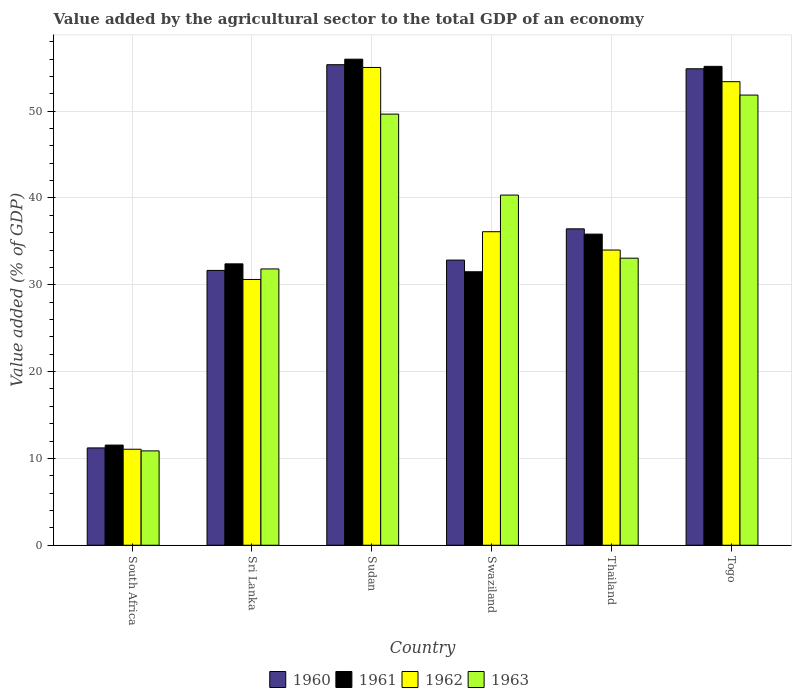How many different coloured bars are there?
Provide a succinct answer. 4. Are the number of bars per tick equal to the number of legend labels?
Provide a succinct answer. Yes. What is the label of the 5th group of bars from the left?
Offer a terse response. Thailand. In how many cases, is the number of bars for a given country not equal to the number of legend labels?
Provide a succinct answer. 0. What is the value added by the agricultural sector to the total GDP in 1962 in Thailand?
Ensure brevity in your answer.  34. Across all countries, what is the maximum value added by the agricultural sector to the total GDP in 1962?
Offer a very short reply. 55.03. Across all countries, what is the minimum value added by the agricultural sector to the total GDP in 1963?
Provide a short and direct response. 10.87. In which country was the value added by the agricultural sector to the total GDP in 1960 maximum?
Provide a succinct answer. Sudan. In which country was the value added by the agricultural sector to the total GDP in 1962 minimum?
Provide a short and direct response. South Africa. What is the total value added by the agricultural sector to the total GDP in 1961 in the graph?
Make the answer very short. 222.43. What is the difference between the value added by the agricultural sector to the total GDP in 1963 in Sudan and that in Swaziland?
Keep it short and to the point. 9.32. What is the difference between the value added by the agricultural sector to the total GDP in 1960 in South Africa and the value added by the agricultural sector to the total GDP in 1961 in Thailand?
Provide a succinct answer. -24.63. What is the average value added by the agricultural sector to the total GDP in 1962 per country?
Provide a short and direct response. 36.7. What is the difference between the value added by the agricultural sector to the total GDP of/in 1961 and value added by the agricultural sector to the total GDP of/in 1962 in Sri Lanka?
Keep it short and to the point. 1.8. In how many countries, is the value added by the agricultural sector to the total GDP in 1963 greater than 2 %?
Your answer should be compact. 6. What is the ratio of the value added by the agricultural sector to the total GDP in 1963 in Swaziland to that in Togo?
Your answer should be compact. 0.78. Is the value added by the agricultural sector to the total GDP in 1961 in Sri Lanka less than that in Thailand?
Provide a short and direct response. Yes. Is the difference between the value added by the agricultural sector to the total GDP in 1961 in South Africa and Thailand greater than the difference between the value added by the agricultural sector to the total GDP in 1962 in South Africa and Thailand?
Offer a very short reply. No. What is the difference between the highest and the second highest value added by the agricultural sector to the total GDP in 1961?
Keep it short and to the point. -19.32. What is the difference between the highest and the lowest value added by the agricultural sector to the total GDP in 1963?
Your response must be concise. 40.98. Is it the case that in every country, the sum of the value added by the agricultural sector to the total GDP in 1960 and value added by the agricultural sector to the total GDP in 1962 is greater than the value added by the agricultural sector to the total GDP in 1963?
Give a very brief answer. Yes. Are the values on the major ticks of Y-axis written in scientific E-notation?
Provide a succinct answer. No. Does the graph contain any zero values?
Make the answer very short. No. Does the graph contain grids?
Keep it short and to the point. Yes. Where does the legend appear in the graph?
Provide a succinct answer. Bottom center. How many legend labels are there?
Make the answer very short. 4. What is the title of the graph?
Offer a terse response. Value added by the agricultural sector to the total GDP of an economy. Does "1985" appear as one of the legend labels in the graph?
Offer a very short reply. No. What is the label or title of the X-axis?
Offer a terse response. Country. What is the label or title of the Y-axis?
Provide a succinct answer. Value added (% of GDP). What is the Value added (% of GDP) in 1960 in South Africa?
Offer a terse response. 11.21. What is the Value added (% of GDP) of 1961 in South Africa?
Provide a succinct answer. 11.54. What is the Value added (% of GDP) in 1962 in South Africa?
Provide a succinct answer. 11.06. What is the Value added (% of GDP) of 1963 in South Africa?
Provide a succinct answer. 10.87. What is the Value added (% of GDP) in 1960 in Sri Lanka?
Keep it short and to the point. 31.66. What is the Value added (% of GDP) of 1961 in Sri Lanka?
Your answer should be compact. 32.41. What is the Value added (% of GDP) in 1962 in Sri Lanka?
Provide a succinct answer. 30.61. What is the Value added (% of GDP) of 1963 in Sri Lanka?
Make the answer very short. 31.83. What is the Value added (% of GDP) in 1960 in Sudan?
Provide a succinct answer. 55.35. What is the Value added (% of GDP) in 1961 in Sudan?
Give a very brief answer. 55.99. What is the Value added (% of GDP) of 1962 in Sudan?
Offer a terse response. 55.03. What is the Value added (% of GDP) in 1963 in Sudan?
Offer a terse response. 49.66. What is the Value added (% of GDP) of 1960 in Swaziland?
Make the answer very short. 32.84. What is the Value added (% of GDP) in 1961 in Swaziland?
Your answer should be very brief. 31.5. What is the Value added (% of GDP) in 1962 in Swaziland?
Provide a succinct answer. 36.11. What is the Value added (% of GDP) in 1963 in Swaziland?
Your answer should be compact. 40.33. What is the Value added (% of GDP) in 1960 in Thailand?
Give a very brief answer. 36.44. What is the Value added (% of GDP) in 1961 in Thailand?
Provide a short and direct response. 35.84. What is the Value added (% of GDP) in 1962 in Thailand?
Your answer should be very brief. 34. What is the Value added (% of GDP) of 1963 in Thailand?
Your answer should be compact. 33.07. What is the Value added (% of GDP) of 1960 in Togo?
Ensure brevity in your answer.  54.88. What is the Value added (% of GDP) of 1961 in Togo?
Provide a short and direct response. 55.16. What is the Value added (% of GDP) in 1962 in Togo?
Ensure brevity in your answer.  53.4. What is the Value added (% of GDP) of 1963 in Togo?
Your answer should be compact. 51.85. Across all countries, what is the maximum Value added (% of GDP) in 1960?
Offer a terse response. 55.35. Across all countries, what is the maximum Value added (% of GDP) in 1961?
Make the answer very short. 55.99. Across all countries, what is the maximum Value added (% of GDP) in 1962?
Provide a short and direct response. 55.03. Across all countries, what is the maximum Value added (% of GDP) in 1963?
Provide a succinct answer. 51.85. Across all countries, what is the minimum Value added (% of GDP) of 1960?
Give a very brief answer. 11.21. Across all countries, what is the minimum Value added (% of GDP) in 1961?
Make the answer very short. 11.54. Across all countries, what is the minimum Value added (% of GDP) of 1962?
Offer a terse response. 11.06. Across all countries, what is the minimum Value added (% of GDP) in 1963?
Your answer should be compact. 10.87. What is the total Value added (% of GDP) in 1960 in the graph?
Offer a very short reply. 222.39. What is the total Value added (% of GDP) of 1961 in the graph?
Your answer should be very brief. 222.44. What is the total Value added (% of GDP) of 1962 in the graph?
Provide a succinct answer. 220.21. What is the total Value added (% of GDP) of 1963 in the graph?
Your answer should be compact. 217.6. What is the difference between the Value added (% of GDP) in 1960 in South Africa and that in Sri Lanka?
Provide a short and direct response. -20.45. What is the difference between the Value added (% of GDP) in 1961 in South Africa and that in Sri Lanka?
Give a very brief answer. -20.87. What is the difference between the Value added (% of GDP) of 1962 in South Africa and that in Sri Lanka?
Your answer should be very brief. -19.56. What is the difference between the Value added (% of GDP) of 1963 in South Africa and that in Sri Lanka?
Your answer should be compact. -20.96. What is the difference between the Value added (% of GDP) of 1960 in South Africa and that in Sudan?
Offer a terse response. -44.14. What is the difference between the Value added (% of GDP) of 1961 in South Africa and that in Sudan?
Make the answer very short. -44.45. What is the difference between the Value added (% of GDP) in 1962 in South Africa and that in Sudan?
Provide a succinct answer. -43.98. What is the difference between the Value added (% of GDP) of 1963 in South Africa and that in Sudan?
Offer a terse response. -38.79. What is the difference between the Value added (% of GDP) in 1960 in South Africa and that in Swaziland?
Your answer should be compact. -21.63. What is the difference between the Value added (% of GDP) of 1961 in South Africa and that in Swaziland?
Make the answer very short. -19.96. What is the difference between the Value added (% of GDP) in 1962 in South Africa and that in Swaziland?
Your answer should be very brief. -25.06. What is the difference between the Value added (% of GDP) of 1963 in South Africa and that in Swaziland?
Your answer should be compact. -29.46. What is the difference between the Value added (% of GDP) in 1960 in South Africa and that in Thailand?
Your response must be concise. -25.23. What is the difference between the Value added (% of GDP) in 1961 in South Africa and that in Thailand?
Your response must be concise. -24.3. What is the difference between the Value added (% of GDP) of 1962 in South Africa and that in Thailand?
Your answer should be very brief. -22.95. What is the difference between the Value added (% of GDP) of 1963 in South Africa and that in Thailand?
Offer a terse response. -22.2. What is the difference between the Value added (% of GDP) of 1960 in South Africa and that in Togo?
Keep it short and to the point. -43.67. What is the difference between the Value added (% of GDP) in 1961 in South Africa and that in Togo?
Make the answer very short. -43.62. What is the difference between the Value added (% of GDP) in 1962 in South Africa and that in Togo?
Your answer should be very brief. -42.34. What is the difference between the Value added (% of GDP) of 1963 in South Africa and that in Togo?
Your response must be concise. -40.98. What is the difference between the Value added (% of GDP) in 1960 in Sri Lanka and that in Sudan?
Give a very brief answer. -23.7. What is the difference between the Value added (% of GDP) in 1961 in Sri Lanka and that in Sudan?
Offer a very short reply. -23.58. What is the difference between the Value added (% of GDP) in 1962 in Sri Lanka and that in Sudan?
Keep it short and to the point. -24.42. What is the difference between the Value added (% of GDP) in 1963 in Sri Lanka and that in Sudan?
Your answer should be very brief. -17.83. What is the difference between the Value added (% of GDP) of 1960 in Sri Lanka and that in Swaziland?
Give a very brief answer. -1.19. What is the difference between the Value added (% of GDP) of 1961 in Sri Lanka and that in Swaziland?
Provide a succinct answer. 0.91. What is the difference between the Value added (% of GDP) in 1962 in Sri Lanka and that in Swaziland?
Keep it short and to the point. -5.5. What is the difference between the Value added (% of GDP) in 1963 in Sri Lanka and that in Swaziland?
Give a very brief answer. -8.51. What is the difference between the Value added (% of GDP) in 1960 in Sri Lanka and that in Thailand?
Give a very brief answer. -4.79. What is the difference between the Value added (% of GDP) in 1961 in Sri Lanka and that in Thailand?
Give a very brief answer. -3.43. What is the difference between the Value added (% of GDP) in 1962 in Sri Lanka and that in Thailand?
Give a very brief answer. -3.39. What is the difference between the Value added (% of GDP) in 1963 in Sri Lanka and that in Thailand?
Provide a succinct answer. -1.24. What is the difference between the Value added (% of GDP) in 1960 in Sri Lanka and that in Togo?
Provide a succinct answer. -23.23. What is the difference between the Value added (% of GDP) of 1961 in Sri Lanka and that in Togo?
Your answer should be very brief. -22.75. What is the difference between the Value added (% of GDP) in 1962 in Sri Lanka and that in Togo?
Make the answer very short. -22.78. What is the difference between the Value added (% of GDP) of 1963 in Sri Lanka and that in Togo?
Keep it short and to the point. -20.03. What is the difference between the Value added (% of GDP) in 1960 in Sudan and that in Swaziland?
Provide a succinct answer. 22.51. What is the difference between the Value added (% of GDP) in 1961 in Sudan and that in Swaziland?
Your response must be concise. 24.49. What is the difference between the Value added (% of GDP) in 1962 in Sudan and that in Swaziland?
Offer a terse response. 18.92. What is the difference between the Value added (% of GDP) of 1963 in Sudan and that in Swaziland?
Your response must be concise. 9.32. What is the difference between the Value added (% of GDP) of 1960 in Sudan and that in Thailand?
Provide a succinct answer. 18.91. What is the difference between the Value added (% of GDP) in 1961 in Sudan and that in Thailand?
Make the answer very short. 20.15. What is the difference between the Value added (% of GDP) of 1962 in Sudan and that in Thailand?
Make the answer very short. 21.03. What is the difference between the Value added (% of GDP) of 1963 in Sudan and that in Thailand?
Provide a short and direct response. 16.59. What is the difference between the Value added (% of GDP) of 1960 in Sudan and that in Togo?
Your response must be concise. 0.47. What is the difference between the Value added (% of GDP) in 1961 in Sudan and that in Togo?
Offer a terse response. 0.83. What is the difference between the Value added (% of GDP) of 1962 in Sudan and that in Togo?
Your answer should be very brief. 1.64. What is the difference between the Value added (% of GDP) in 1963 in Sudan and that in Togo?
Your answer should be very brief. -2.19. What is the difference between the Value added (% of GDP) in 1960 in Swaziland and that in Thailand?
Make the answer very short. -3.6. What is the difference between the Value added (% of GDP) of 1961 in Swaziland and that in Thailand?
Offer a very short reply. -4.34. What is the difference between the Value added (% of GDP) of 1962 in Swaziland and that in Thailand?
Keep it short and to the point. 2.11. What is the difference between the Value added (% of GDP) in 1963 in Swaziland and that in Thailand?
Offer a very short reply. 7.27. What is the difference between the Value added (% of GDP) of 1960 in Swaziland and that in Togo?
Give a very brief answer. -22.04. What is the difference between the Value added (% of GDP) in 1961 in Swaziland and that in Togo?
Keep it short and to the point. -23.66. What is the difference between the Value added (% of GDP) in 1962 in Swaziland and that in Togo?
Provide a short and direct response. -17.28. What is the difference between the Value added (% of GDP) of 1963 in Swaziland and that in Togo?
Offer a terse response. -11.52. What is the difference between the Value added (% of GDP) in 1960 in Thailand and that in Togo?
Your response must be concise. -18.44. What is the difference between the Value added (% of GDP) in 1961 in Thailand and that in Togo?
Make the answer very short. -19.32. What is the difference between the Value added (% of GDP) of 1962 in Thailand and that in Togo?
Provide a short and direct response. -19.39. What is the difference between the Value added (% of GDP) of 1963 in Thailand and that in Togo?
Ensure brevity in your answer.  -18.79. What is the difference between the Value added (% of GDP) in 1960 in South Africa and the Value added (% of GDP) in 1961 in Sri Lanka?
Make the answer very short. -21.2. What is the difference between the Value added (% of GDP) of 1960 in South Africa and the Value added (% of GDP) of 1962 in Sri Lanka?
Offer a very short reply. -19.4. What is the difference between the Value added (% of GDP) in 1960 in South Africa and the Value added (% of GDP) in 1963 in Sri Lanka?
Keep it short and to the point. -20.62. What is the difference between the Value added (% of GDP) in 1961 in South Africa and the Value added (% of GDP) in 1962 in Sri Lanka?
Provide a short and direct response. -19.08. What is the difference between the Value added (% of GDP) of 1961 in South Africa and the Value added (% of GDP) of 1963 in Sri Lanka?
Ensure brevity in your answer.  -20.29. What is the difference between the Value added (% of GDP) in 1962 in South Africa and the Value added (% of GDP) in 1963 in Sri Lanka?
Offer a very short reply. -20.77. What is the difference between the Value added (% of GDP) in 1960 in South Africa and the Value added (% of GDP) in 1961 in Sudan?
Make the answer very short. -44.78. What is the difference between the Value added (% of GDP) in 1960 in South Africa and the Value added (% of GDP) in 1962 in Sudan?
Make the answer very short. -43.82. What is the difference between the Value added (% of GDP) in 1960 in South Africa and the Value added (% of GDP) in 1963 in Sudan?
Keep it short and to the point. -38.45. What is the difference between the Value added (% of GDP) in 1961 in South Africa and the Value added (% of GDP) in 1962 in Sudan?
Your answer should be compact. -43.5. What is the difference between the Value added (% of GDP) in 1961 in South Africa and the Value added (% of GDP) in 1963 in Sudan?
Offer a very short reply. -38.12. What is the difference between the Value added (% of GDP) of 1962 in South Africa and the Value added (% of GDP) of 1963 in Sudan?
Offer a terse response. -38.6. What is the difference between the Value added (% of GDP) of 1960 in South Africa and the Value added (% of GDP) of 1961 in Swaziland?
Provide a succinct answer. -20.29. What is the difference between the Value added (% of GDP) in 1960 in South Africa and the Value added (% of GDP) in 1962 in Swaziland?
Make the answer very short. -24.9. What is the difference between the Value added (% of GDP) in 1960 in South Africa and the Value added (% of GDP) in 1963 in Swaziland?
Keep it short and to the point. -29.12. What is the difference between the Value added (% of GDP) in 1961 in South Africa and the Value added (% of GDP) in 1962 in Swaziland?
Offer a terse response. -24.58. What is the difference between the Value added (% of GDP) in 1961 in South Africa and the Value added (% of GDP) in 1963 in Swaziland?
Provide a short and direct response. -28.8. What is the difference between the Value added (% of GDP) of 1962 in South Africa and the Value added (% of GDP) of 1963 in Swaziland?
Offer a terse response. -29.28. What is the difference between the Value added (% of GDP) in 1960 in South Africa and the Value added (% of GDP) in 1961 in Thailand?
Your response must be concise. -24.63. What is the difference between the Value added (% of GDP) in 1960 in South Africa and the Value added (% of GDP) in 1962 in Thailand?
Keep it short and to the point. -22.79. What is the difference between the Value added (% of GDP) of 1960 in South Africa and the Value added (% of GDP) of 1963 in Thailand?
Keep it short and to the point. -21.86. What is the difference between the Value added (% of GDP) in 1961 in South Africa and the Value added (% of GDP) in 1962 in Thailand?
Give a very brief answer. -22.47. What is the difference between the Value added (% of GDP) in 1961 in South Africa and the Value added (% of GDP) in 1963 in Thailand?
Provide a short and direct response. -21.53. What is the difference between the Value added (% of GDP) of 1962 in South Africa and the Value added (% of GDP) of 1963 in Thailand?
Offer a very short reply. -22.01. What is the difference between the Value added (% of GDP) in 1960 in South Africa and the Value added (% of GDP) in 1961 in Togo?
Keep it short and to the point. -43.95. What is the difference between the Value added (% of GDP) of 1960 in South Africa and the Value added (% of GDP) of 1962 in Togo?
Offer a terse response. -42.18. What is the difference between the Value added (% of GDP) of 1960 in South Africa and the Value added (% of GDP) of 1963 in Togo?
Your answer should be compact. -40.64. What is the difference between the Value added (% of GDP) of 1961 in South Africa and the Value added (% of GDP) of 1962 in Togo?
Your answer should be compact. -41.86. What is the difference between the Value added (% of GDP) in 1961 in South Africa and the Value added (% of GDP) in 1963 in Togo?
Keep it short and to the point. -40.31. What is the difference between the Value added (% of GDP) of 1962 in South Africa and the Value added (% of GDP) of 1963 in Togo?
Offer a terse response. -40.8. What is the difference between the Value added (% of GDP) in 1960 in Sri Lanka and the Value added (% of GDP) in 1961 in Sudan?
Your answer should be compact. -24.33. What is the difference between the Value added (% of GDP) in 1960 in Sri Lanka and the Value added (% of GDP) in 1962 in Sudan?
Ensure brevity in your answer.  -23.38. What is the difference between the Value added (% of GDP) of 1960 in Sri Lanka and the Value added (% of GDP) of 1963 in Sudan?
Give a very brief answer. -18. What is the difference between the Value added (% of GDP) in 1961 in Sri Lanka and the Value added (% of GDP) in 1962 in Sudan?
Ensure brevity in your answer.  -22.62. What is the difference between the Value added (% of GDP) of 1961 in Sri Lanka and the Value added (% of GDP) of 1963 in Sudan?
Keep it short and to the point. -17.25. What is the difference between the Value added (% of GDP) of 1962 in Sri Lanka and the Value added (% of GDP) of 1963 in Sudan?
Give a very brief answer. -19.04. What is the difference between the Value added (% of GDP) of 1960 in Sri Lanka and the Value added (% of GDP) of 1961 in Swaziland?
Your answer should be very brief. 0.16. What is the difference between the Value added (% of GDP) in 1960 in Sri Lanka and the Value added (% of GDP) in 1962 in Swaziland?
Make the answer very short. -4.46. What is the difference between the Value added (% of GDP) of 1960 in Sri Lanka and the Value added (% of GDP) of 1963 in Swaziland?
Provide a succinct answer. -8.68. What is the difference between the Value added (% of GDP) in 1961 in Sri Lanka and the Value added (% of GDP) in 1962 in Swaziland?
Your answer should be compact. -3.7. What is the difference between the Value added (% of GDP) of 1961 in Sri Lanka and the Value added (% of GDP) of 1963 in Swaziland?
Your response must be concise. -7.92. What is the difference between the Value added (% of GDP) in 1962 in Sri Lanka and the Value added (% of GDP) in 1963 in Swaziland?
Make the answer very short. -9.72. What is the difference between the Value added (% of GDP) in 1960 in Sri Lanka and the Value added (% of GDP) in 1961 in Thailand?
Keep it short and to the point. -4.18. What is the difference between the Value added (% of GDP) in 1960 in Sri Lanka and the Value added (% of GDP) in 1962 in Thailand?
Provide a succinct answer. -2.35. What is the difference between the Value added (% of GDP) of 1960 in Sri Lanka and the Value added (% of GDP) of 1963 in Thailand?
Your response must be concise. -1.41. What is the difference between the Value added (% of GDP) in 1961 in Sri Lanka and the Value added (% of GDP) in 1962 in Thailand?
Your answer should be compact. -1.59. What is the difference between the Value added (% of GDP) of 1961 in Sri Lanka and the Value added (% of GDP) of 1963 in Thailand?
Make the answer very short. -0.65. What is the difference between the Value added (% of GDP) of 1962 in Sri Lanka and the Value added (% of GDP) of 1963 in Thailand?
Make the answer very short. -2.45. What is the difference between the Value added (% of GDP) of 1960 in Sri Lanka and the Value added (% of GDP) of 1961 in Togo?
Your answer should be very brief. -23.51. What is the difference between the Value added (% of GDP) in 1960 in Sri Lanka and the Value added (% of GDP) in 1962 in Togo?
Provide a succinct answer. -21.74. What is the difference between the Value added (% of GDP) of 1960 in Sri Lanka and the Value added (% of GDP) of 1963 in Togo?
Ensure brevity in your answer.  -20.2. What is the difference between the Value added (% of GDP) of 1961 in Sri Lanka and the Value added (% of GDP) of 1962 in Togo?
Your answer should be compact. -20.98. What is the difference between the Value added (% of GDP) of 1961 in Sri Lanka and the Value added (% of GDP) of 1963 in Togo?
Provide a succinct answer. -19.44. What is the difference between the Value added (% of GDP) in 1962 in Sri Lanka and the Value added (% of GDP) in 1963 in Togo?
Provide a succinct answer. -21.24. What is the difference between the Value added (% of GDP) of 1960 in Sudan and the Value added (% of GDP) of 1961 in Swaziland?
Provide a succinct answer. 23.85. What is the difference between the Value added (% of GDP) of 1960 in Sudan and the Value added (% of GDP) of 1962 in Swaziland?
Your response must be concise. 19.24. What is the difference between the Value added (% of GDP) of 1960 in Sudan and the Value added (% of GDP) of 1963 in Swaziland?
Ensure brevity in your answer.  15.02. What is the difference between the Value added (% of GDP) of 1961 in Sudan and the Value added (% of GDP) of 1962 in Swaziland?
Provide a succinct answer. 19.87. What is the difference between the Value added (% of GDP) of 1961 in Sudan and the Value added (% of GDP) of 1963 in Swaziland?
Your response must be concise. 15.65. What is the difference between the Value added (% of GDP) of 1962 in Sudan and the Value added (% of GDP) of 1963 in Swaziland?
Provide a short and direct response. 14.7. What is the difference between the Value added (% of GDP) of 1960 in Sudan and the Value added (% of GDP) of 1961 in Thailand?
Your response must be concise. 19.51. What is the difference between the Value added (% of GDP) in 1960 in Sudan and the Value added (% of GDP) in 1962 in Thailand?
Your answer should be compact. 21.35. What is the difference between the Value added (% of GDP) in 1960 in Sudan and the Value added (% of GDP) in 1963 in Thailand?
Your response must be concise. 22.29. What is the difference between the Value added (% of GDP) in 1961 in Sudan and the Value added (% of GDP) in 1962 in Thailand?
Keep it short and to the point. 21.98. What is the difference between the Value added (% of GDP) in 1961 in Sudan and the Value added (% of GDP) in 1963 in Thailand?
Keep it short and to the point. 22.92. What is the difference between the Value added (% of GDP) in 1962 in Sudan and the Value added (% of GDP) in 1963 in Thailand?
Give a very brief answer. 21.97. What is the difference between the Value added (% of GDP) of 1960 in Sudan and the Value added (% of GDP) of 1961 in Togo?
Ensure brevity in your answer.  0.19. What is the difference between the Value added (% of GDP) in 1960 in Sudan and the Value added (% of GDP) in 1962 in Togo?
Offer a terse response. 1.96. What is the difference between the Value added (% of GDP) of 1960 in Sudan and the Value added (% of GDP) of 1963 in Togo?
Offer a terse response. 3.5. What is the difference between the Value added (% of GDP) in 1961 in Sudan and the Value added (% of GDP) in 1962 in Togo?
Ensure brevity in your answer.  2.59. What is the difference between the Value added (% of GDP) of 1961 in Sudan and the Value added (% of GDP) of 1963 in Togo?
Provide a short and direct response. 4.13. What is the difference between the Value added (% of GDP) of 1962 in Sudan and the Value added (% of GDP) of 1963 in Togo?
Offer a very short reply. 3.18. What is the difference between the Value added (% of GDP) in 1960 in Swaziland and the Value added (% of GDP) in 1961 in Thailand?
Provide a succinct answer. -2.99. What is the difference between the Value added (% of GDP) of 1960 in Swaziland and the Value added (% of GDP) of 1962 in Thailand?
Your answer should be very brief. -1.16. What is the difference between the Value added (% of GDP) in 1960 in Swaziland and the Value added (% of GDP) in 1963 in Thailand?
Your response must be concise. -0.22. What is the difference between the Value added (% of GDP) of 1961 in Swaziland and the Value added (% of GDP) of 1962 in Thailand?
Keep it short and to the point. -2.5. What is the difference between the Value added (% of GDP) in 1961 in Swaziland and the Value added (% of GDP) in 1963 in Thailand?
Your answer should be compact. -1.57. What is the difference between the Value added (% of GDP) in 1962 in Swaziland and the Value added (% of GDP) in 1963 in Thailand?
Offer a terse response. 3.05. What is the difference between the Value added (% of GDP) in 1960 in Swaziland and the Value added (% of GDP) in 1961 in Togo?
Offer a very short reply. -22.32. What is the difference between the Value added (% of GDP) in 1960 in Swaziland and the Value added (% of GDP) in 1962 in Togo?
Your answer should be compact. -20.55. What is the difference between the Value added (% of GDP) in 1960 in Swaziland and the Value added (% of GDP) in 1963 in Togo?
Offer a terse response. -19.01. What is the difference between the Value added (% of GDP) in 1961 in Swaziland and the Value added (% of GDP) in 1962 in Togo?
Provide a succinct answer. -21.9. What is the difference between the Value added (% of GDP) in 1961 in Swaziland and the Value added (% of GDP) in 1963 in Togo?
Your answer should be very brief. -20.35. What is the difference between the Value added (% of GDP) in 1962 in Swaziland and the Value added (% of GDP) in 1963 in Togo?
Keep it short and to the point. -15.74. What is the difference between the Value added (% of GDP) of 1960 in Thailand and the Value added (% of GDP) of 1961 in Togo?
Ensure brevity in your answer.  -18.72. What is the difference between the Value added (% of GDP) in 1960 in Thailand and the Value added (% of GDP) in 1962 in Togo?
Your answer should be very brief. -16.95. What is the difference between the Value added (% of GDP) in 1960 in Thailand and the Value added (% of GDP) in 1963 in Togo?
Provide a succinct answer. -15.41. What is the difference between the Value added (% of GDP) in 1961 in Thailand and the Value added (% of GDP) in 1962 in Togo?
Your response must be concise. -17.56. What is the difference between the Value added (% of GDP) of 1961 in Thailand and the Value added (% of GDP) of 1963 in Togo?
Offer a very short reply. -16.01. What is the difference between the Value added (% of GDP) in 1962 in Thailand and the Value added (% of GDP) in 1963 in Togo?
Your response must be concise. -17.85. What is the average Value added (% of GDP) in 1960 per country?
Your answer should be very brief. 37.06. What is the average Value added (% of GDP) of 1961 per country?
Ensure brevity in your answer.  37.07. What is the average Value added (% of GDP) in 1962 per country?
Offer a terse response. 36.7. What is the average Value added (% of GDP) of 1963 per country?
Your answer should be very brief. 36.27. What is the difference between the Value added (% of GDP) in 1960 and Value added (% of GDP) in 1961 in South Africa?
Offer a very short reply. -0.33. What is the difference between the Value added (% of GDP) of 1960 and Value added (% of GDP) of 1962 in South Africa?
Provide a succinct answer. 0.15. What is the difference between the Value added (% of GDP) of 1960 and Value added (% of GDP) of 1963 in South Africa?
Give a very brief answer. 0.34. What is the difference between the Value added (% of GDP) of 1961 and Value added (% of GDP) of 1962 in South Africa?
Offer a terse response. 0.48. What is the difference between the Value added (% of GDP) of 1961 and Value added (% of GDP) of 1963 in South Africa?
Provide a succinct answer. 0.67. What is the difference between the Value added (% of GDP) of 1962 and Value added (% of GDP) of 1963 in South Africa?
Your answer should be compact. 0.19. What is the difference between the Value added (% of GDP) of 1960 and Value added (% of GDP) of 1961 in Sri Lanka?
Provide a short and direct response. -0.76. What is the difference between the Value added (% of GDP) in 1960 and Value added (% of GDP) in 1962 in Sri Lanka?
Provide a short and direct response. 1.04. What is the difference between the Value added (% of GDP) in 1960 and Value added (% of GDP) in 1963 in Sri Lanka?
Your answer should be very brief. -0.17. What is the difference between the Value added (% of GDP) of 1961 and Value added (% of GDP) of 1962 in Sri Lanka?
Provide a succinct answer. 1.8. What is the difference between the Value added (% of GDP) in 1961 and Value added (% of GDP) in 1963 in Sri Lanka?
Provide a succinct answer. 0.59. What is the difference between the Value added (% of GDP) of 1962 and Value added (% of GDP) of 1963 in Sri Lanka?
Offer a very short reply. -1.21. What is the difference between the Value added (% of GDP) of 1960 and Value added (% of GDP) of 1961 in Sudan?
Ensure brevity in your answer.  -0.64. What is the difference between the Value added (% of GDP) of 1960 and Value added (% of GDP) of 1962 in Sudan?
Offer a terse response. 0.32. What is the difference between the Value added (% of GDP) of 1960 and Value added (% of GDP) of 1963 in Sudan?
Keep it short and to the point. 5.69. What is the difference between the Value added (% of GDP) in 1961 and Value added (% of GDP) in 1962 in Sudan?
Offer a terse response. 0.95. What is the difference between the Value added (% of GDP) of 1961 and Value added (% of GDP) of 1963 in Sudan?
Make the answer very short. 6.33. What is the difference between the Value added (% of GDP) in 1962 and Value added (% of GDP) in 1963 in Sudan?
Provide a short and direct response. 5.37. What is the difference between the Value added (% of GDP) in 1960 and Value added (% of GDP) in 1961 in Swaziland?
Provide a short and direct response. 1.35. What is the difference between the Value added (% of GDP) of 1960 and Value added (% of GDP) of 1962 in Swaziland?
Provide a succinct answer. -3.27. What is the difference between the Value added (% of GDP) in 1960 and Value added (% of GDP) in 1963 in Swaziland?
Keep it short and to the point. -7.49. What is the difference between the Value added (% of GDP) in 1961 and Value added (% of GDP) in 1962 in Swaziland?
Provide a short and direct response. -4.61. What is the difference between the Value added (% of GDP) in 1961 and Value added (% of GDP) in 1963 in Swaziland?
Ensure brevity in your answer.  -8.83. What is the difference between the Value added (% of GDP) of 1962 and Value added (% of GDP) of 1963 in Swaziland?
Ensure brevity in your answer.  -4.22. What is the difference between the Value added (% of GDP) of 1960 and Value added (% of GDP) of 1961 in Thailand?
Provide a short and direct response. 0.61. What is the difference between the Value added (% of GDP) in 1960 and Value added (% of GDP) in 1962 in Thailand?
Offer a very short reply. 2.44. What is the difference between the Value added (% of GDP) in 1960 and Value added (% of GDP) in 1963 in Thailand?
Your answer should be compact. 3.38. What is the difference between the Value added (% of GDP) in 1961 and Value added (% of GDP) in 1962 in Thailand?
Your answer should be very brief. 1.84. What is the difference between the Value added (% of GDP) of 1961 and Value added (% of GDP) of 1963 in Thailand?
Offer a very short reply. 2.77. What is the difference between the Value added (% of GDP) in 1962 and Value added (% of GDP) in 1963 in Thailand?
Offer a terse response. 0.94. What is the difference between the Value added (% of GDP) of 1960 and Value added (% of GDP) of 1961 in Togo?
Give a very brief answer. -0.28. What is the difference between the Value added (% of GDP) of 1960 and Value added (% of GDP) of 1962 in Togo?
Ensure brevity in your answer.  1.49. What is the difference between the Value added (% of GDP) of 1960 and Value added (% of GDP) of 1963 in Togo?
Offer a terse response. 3.03. What is the difference between the Value added (% of GDP) of 1961 and Value added (% of GDP) of 1962 in Togo?
Your response must be concise. 1.77. What is the difference between the Value added (% of GDP) of 1961 and Value added (% of GDP) of 1963 in Togo?
Provide a succinct answer. 3.31. What is the difference between the Value added (% of GDP) in 1962 and Value added (% of GDP) in 1963 in Togo?
Your response must be concise. 1.54. What is the ratio of the Value added (% of GDP) of 1960 in South Africa to that in Sri Lanka?
Keep it short and to the point. 0.35. What is the ratio of the Value added (% of GDP) in 1961 in South Africa to that in Sri Lanka?
Your response must be concise. 0.36. What is the ratio of the Value added (% of GDP) of 1962 in South Africa to that in Sri Lanka?
Make the answer very short. 0.36. What is the ratio of the Value added (% of GDP) in 1963 in South Africa to that in Sri Lanka?
Your answer should be very brief. 0.34. What is the ratio of the Value added (% of GDP) of 1960 in South Africa to that in Sudan?
Ensure brevity in your answer.  0.2. What is the ratio of the Value added (% of GDP) in 1961 in South Africa to that in Sudan?
Keep it short and to the point. 0.21. What is the ratio of the Value added (% of GDP) in 1962 in South Africa to that in Sudan?
Give a very brief answer. 0.2. What is the ratio of the Value added (% of GDP) of 1963 in South Africa to that in Sudan?
Provide a short and direct response. 0.22. What is the ratio of the Value added (% of GDP) of 1960 in South Africa to that in Swaziland?
Offer a terse response. 0.34. What is the ratio of the Value added (% of GDP) of 1961 in South Africa to that in Swaziland?
Offer a terse response. 0.37. What is the ratio of the Value added (% of GDP) of 1962 in South Africa to that in Swaziland?
Offer a terse response. 0.31. What is the ratio of the Value added (% of GDP) of 1963 in South Africa to that in Swaziland?
Offer a very short reply. 0.27. What is the ratio of the Value added (% of GDP) in 1960 in South Africa to that in Thailand?
Ensure brevity in your answer.  0.31. What is the ratio of the Value added (% of GDP) in 1961 in South Africa to that in Thailand?
Offer a very short reply. 0.32. What is the ratio of the Value added (% of GDP) of 1962 in South Africa to that in Thailand?
Offer a very short reply. 0.33. What is the ratio of the Value added (% of GDP) in 1963 in South Africa to that in Thailand?
Your answer should be compact. 0.33. What is the ratio of the Value added (% of GDP) in 1960 in South Africa to that in Togo?
Provide a short and direct response. 0.2. What is the ratio of the Value added (% of GDP) of 1961 in South Africa to that in Togo?
Give a very brief answer. 0.21. What is the ratio of the Value added (% of GDP) of 1962 in South Africa to that in Togo?
Your response must be concise. 0.21. What is the ratio of the Value added (% of GDP) of 1963 in South Africa to that in Togo?
Keep it short and to the point. 0.21. What is the ratio of the Value added (% of GDP) of 1960 in Sri Lanka to that in Sudan?
Provide a short and direct response. 0.57. What is the ratio of the Value added (% of GDP) in 1961 in Sri Lanka to that in Sudan?
Your answer should be compact. 0.58. What is the ratio of the Value added (% of GDP) of 1962 in Sri Lanka to that in Sudan?
Offer a terse response. 0.56. What is the ratio of the Value added (% of GDP) in 1963 in Sri Lanka to that in Sudan?
Keep it short and to the point. 0.64. What is the ratio of the Value added (% of GDP) of 1960 in Sri Lanka to that in Swaziland?
Offer a very short reply. 0.96. What is the ratio of the Value added (% of GDP) in 1961 in Sri Lanka to that in Swaziland?
Give a very brief answer. 1.03. What is the ratio of the Value added (% of GDP) in 1962 in Sri Lanka to that in Swaziland?
Offer a very short reply. 0.85. What is the ratio of the Value added (% of GDP) in 1963 in Sri Lanka to that in Swaziland?
Ensure brevity in your answer.  0.79. What is the ratio of the Value added (% of GDP) of 1960 in Sri Lanka to that in Thailand?
Keep it short and to the point. 0.87. What is the ratio of the Value added (% of GDP) in 1961 in Sri Lanka to that in Thailand?
Provide a short and direct response. 0.9. What is the ratio of the Value added (% of GDP) of 1962 in Sri Lanka to that in Thailand?
Provide a short and direct response. 0.9. What is the ratio of the Value added (% of GDP) of 1963 in Sri Lanka to that in Thailand?
Your response must be concise. 0.96. What is the ratio of the Value added (% of GDP) of 1960 in Sri Lanka to that in Togo?
Give a very brief answer. 0.58. What is the ratio of the Value added (% of GDP) of 1961 in Sri Lanka to that in Togo?
Provide a short and direct response. 0.59. What is the ratio of the Value added (% of GDP) in 1962 in Sri Lanka to that in Togo?
Offer a terse response. 0.57. What is the ratio of the Value added (% of GDP) of 1963 in Sri Lanka to that in Togo?
Provide a succinct answer. 0.61. What is the ratio of the Value added (% of GDP) in 1960 in Sudan to that in Swaziland?
Keep it short and to the point. 1.69. What is the ratio of the Value added (% of GDP) in 1961 in Sudan to that in Swaziland?
Ensure brevity in your answer.  1.78. What is the ratio of the Value added (% of GDP) in 1962 in Sudan to that in Swaziland?
Provide a succinct answer. 1.52. What is the ratio of the Value added (% of GDP) of 1963 in Sudan to that in Swaziland?
Ensure brevity in your answer.  1.23. What is the ratio of the Value added (% of GDP) of 1960 in Sudan to that in Thailand?
Ensure brevity in your answer.  1.52. What is the ratio of the Value added (% of GDP) in 1961 in Sudan to that in Thailand?
Your answer should be compact. 1.56. What is the ratio of the Value added (% of GDP) of 1962 in Sudan to that in Thailand?
Ensure brevity in your answer.  1.62. What is the ratio of the Value added (% of GDP) in 1963 in Sudan to that in Thailand?
Provide a short and direct response. 1.5. What is the ratio of the Value added (% of GDP) of 1960 in Sudan to that in Togo?
Provide a succinct answer. 1.01. What is the ratio of the Value added (% of GDP) in 1962 in Sudan to that in Togo?
Keep it short and to the point. 1.03. What is the ratio of the Value added (% of GDP) in 1963 in Sudan to that in Togo?
Keep it short and to the point. 0.96. What is the ratio of the Value added (% of GDP) in 1960 in Swaziland to that in Thailand?
Keep it short and to the point. 0.9. What is the ratio of the Value added (% of GDP) of 1961 in Swaziland to that in Thailand?
Give a very brief answer. 0.88. What is the ratio of the Value added (% of GDP) of 1962 in Swaziland to that in Thailand?
Your response must be concise. 1.06. What is the ratio of the Value added (% of GDP) in 1963 in Swaziland to that in Thailand?
Your answer should be compact. 1.22. What is the ratio of the Value added (% of GDP) of 1960 in Swaziland to that in Togo?
Offer a terse response. 0.6. What is the ratio of the Value added (% of GDP) in 1961 in Swaziland to that in Togo?
Your answer should be very brief. 0.57. What is the ratio of the Value added (% of GDP) in 1962 in Swaziland to that in Togo?
Make the answer very short. 0.68. What is the ratio of the Value added (% of GDP) of 1963 in Swaziland to that in Togo?
Ensure brevity in your answer.  0.78. What is the ratio of the Value added (% of GDP) in 1960 in Thailand to that in Togo?
Provide a succinct answer. 0.66. What is the ratio of the Value added (% of GDP) in 1961 in Thailand to that in Togo?
Your answer should be compact. 0.65. What is the ratio of the Value added (% of GDP) in 1962 in Thailand to that in Togo?
Your response must be concise. 0.64. What is the ratio of the Value added (% of GDP) of 1963 in Thailand to that in Togo?
Offer a very short reply. 0.64. What is the difference between the highest and the second highest Value added (% of GDP) in 1960?
Offer a very short reply. 0.47. What is the difference between the highest and the second highest Value added (% of GDP) in 1961?
Ensure brevity in your answer.  0.83. What is the difference between the highest and the second highest Value added (% of GDP) in 1962?
Provide a short and direct response. 1.64. What is the difference between the highest and the second highest Value added (% of GDP) in 1963?
Your response must be concise. 2.19. What is the difference between the highest and the lowest Value added (% of GDP) of 1960?
Make the answer very short. 44.14. What is the difference between the highest and the lowest Value added (% of GDP) of 1961?
Your answer should be very brief. 44.45. What is the difference between the highest and the lowest Value added (% of GDP) in 1962?
Keep it short and to the point. 43.98. What is the difference between the highest and the lowest Value added (% of GDP) in 1963?
Keep it short and to the point. 40.98. 